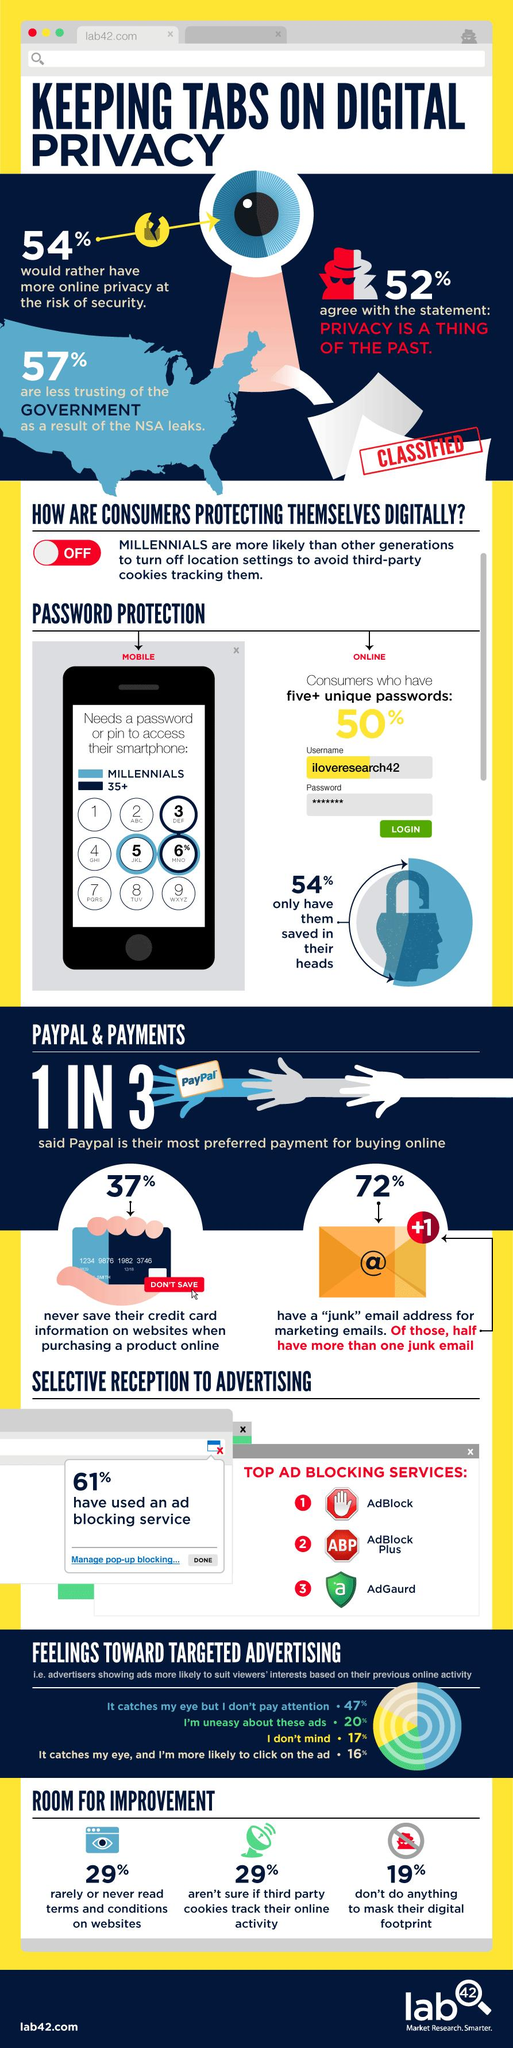Highlight a few significant elements in this photo. According to the survey, 39% of respondents do not use any ad blocking service. According to a survey, 19% of people do not care about hiding their online activities. According to the survey, 46% of people do not want to have online privacy. Despite recent events, 47% of people still trust the government. According to the given percentage, approximately 29% of people never read the terms and conditions or are unsure if their online activity is being tracked. 